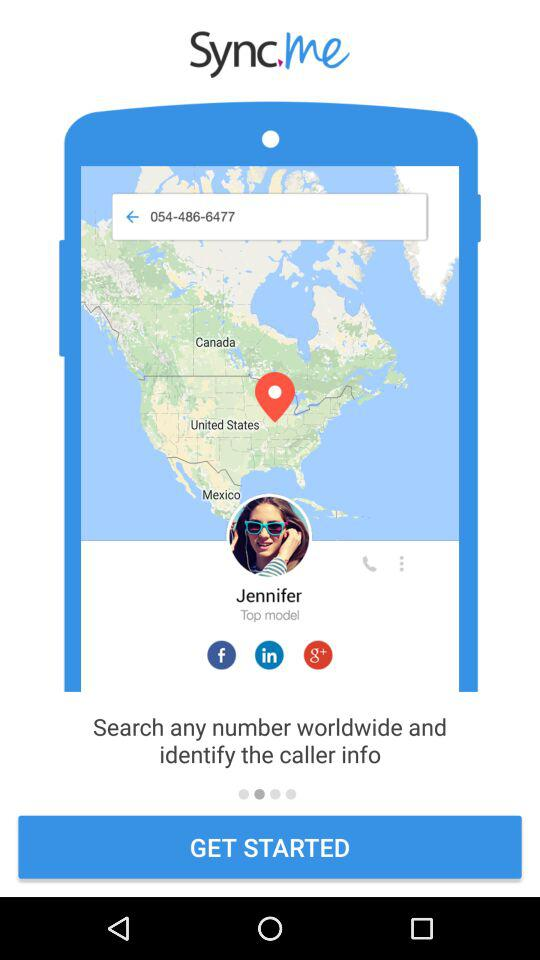What is the number in the search box? The number is 054-486-6477. 